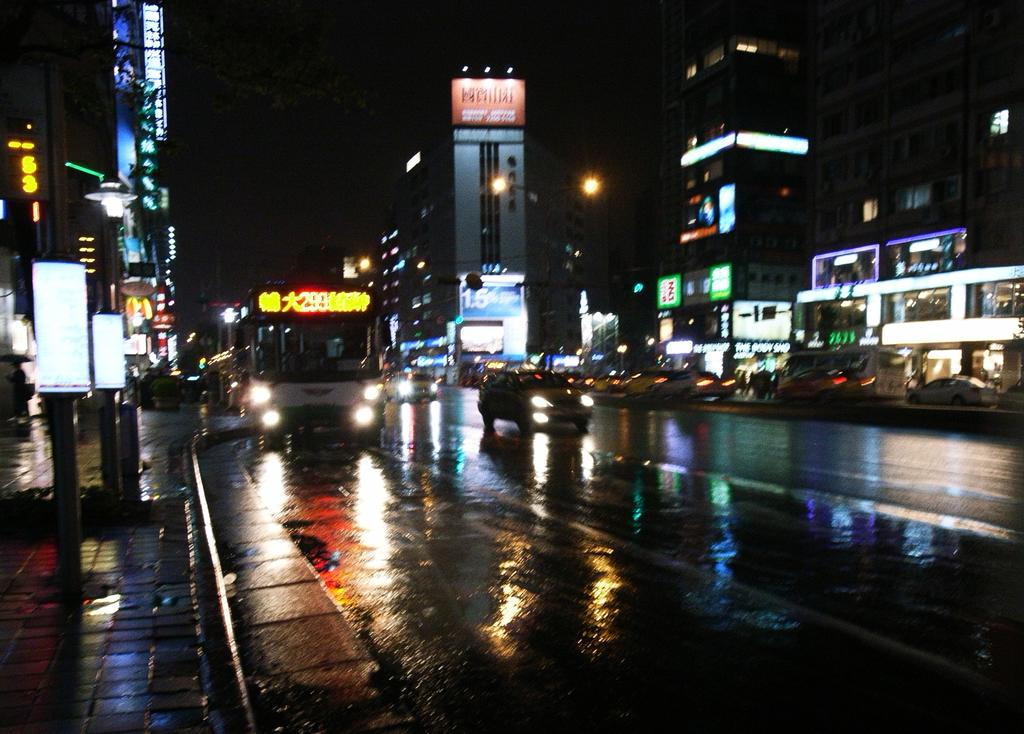What is the lighting condition in the image? The image is taken in the dark. What is happening on the road in the image? Vehicles are moving on the road in the image. What objects can be seen in the image that are used for displaying information or advertisements? Boards are visible in the image. What type of structures are present in the image that support wires or other objects? Poles are present in the image. What type of structures are visible in the image that are used for housing people or businesses? Buildings are visible in the image. What type of poles are present in the image that provide illumination? Light poles are present in the image. What is visible in the background of the image? The sky is visible in the background of the image. What type of cake is being distributed in the image? There is no cake present in the image, and therefore no distribution is taking place. What type of trade is being conducted in the image? There is no trade being conducted in the image; it primarily shows vehicles moving on the road and the surrounding environment. 